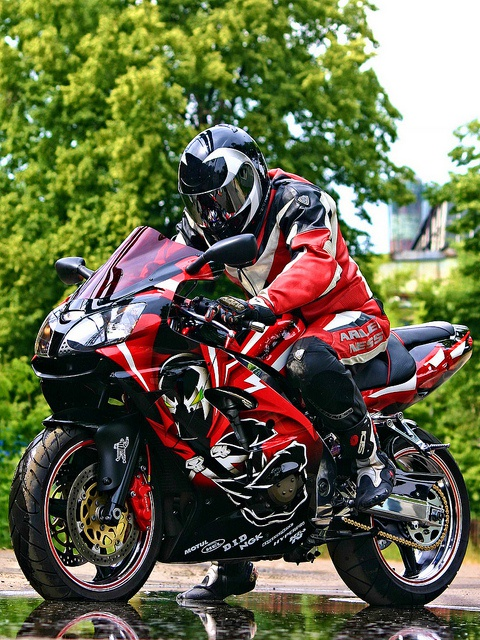Describe the objects in this image and their specific colors. I can see motorcycle in olive, black, lightgray, gray, and darkgray tones and people in olive, black, white, brown, and gray tones in this image. 